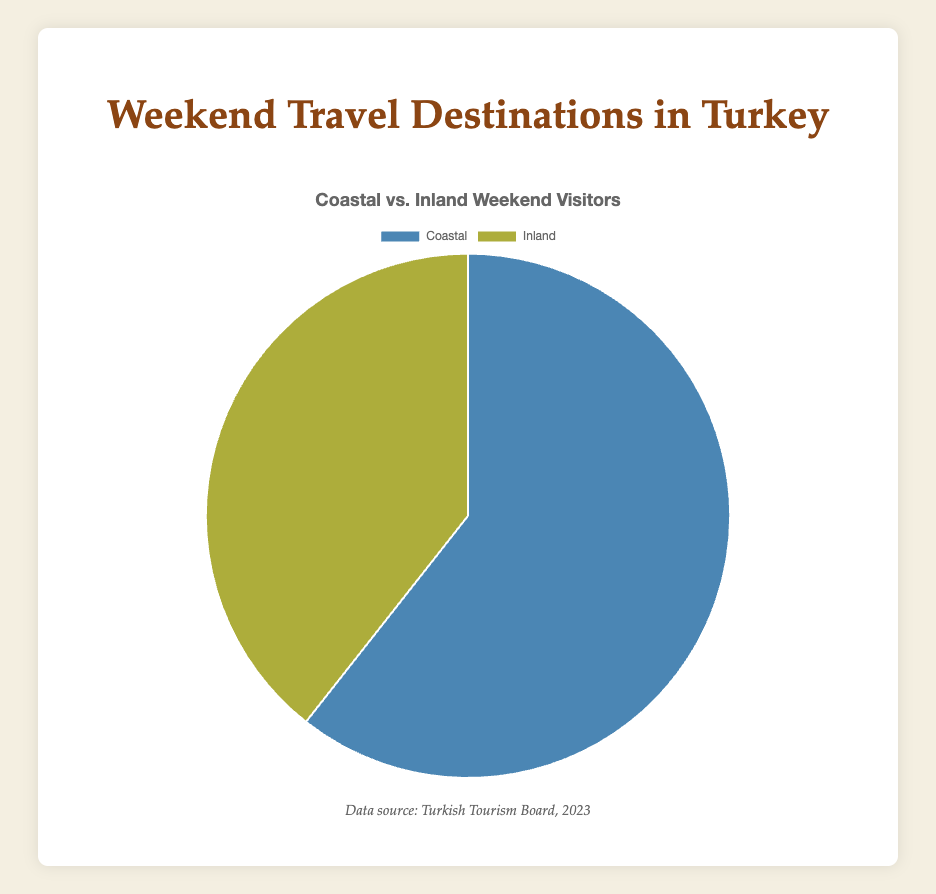What's the total number of weekend visitors to coastal destinations? To find the total number of weekend visitors to coastal destinations, sum up the visitors to Antalya, Bodrum, and Izmir: 50,000 + 30,000 + 20,000 = 100,000
Answer: 100,000 Which destination has the highest number of weekend visitors, coastal or inland? Comparing the totals, coastal destinations have 100,000 visitors and inland destinations have 65,000 visitors; coastal is higher
Answer: Coastal What's the average number of weekend visitors to inland destinations? To find the average, sum up the visitors to Cappadocia, Ankara, and Konya: 40,000 + 15,000 + 10,000 = 65,000. Then divide by 3: 65,000 ÷ 3 ≈ 21,666.67
Answer: 21,666.67 Which color represents coastal destinations in the pie chart? The pie chart uses a legend and the color assignment, coastal destinations are represented by blue shades
Answer: Blue How many more weekend visitors do coastal destinations have compared to inland destinations? To find the difference, subtract inland visitors from coastal visitors: 100,000 - 65,000 = 35,000
Answer: 35,000 What's the percentage of total weekend visitors going to inland destinations? First, calculate the total visitors (coastal + inland): 100,000 + 65,000 = 165,000. Then, find the percentage for inland: (65,000 ÷ 165,000) × 100 ≈ 39.39%
Answer: 39.39% Which destination, coastal or inland, has a higher average number of visitors per location? Find the averages: Coastal: (50,000 + 30,000 + 20,000) ÷ 3 = 33,333.33, Inland: (40,000 + 15,000 + 10,000) ÷ 3 = 21,666.67; coastal has a higher average
Answer: Coastal What's the cumulative percentage of visitors for coastal destinations? Since coastal visitors are 100,000 and the total is 165,000, calculate (100,000 ÷ 165,000) × 100 ≈ 60.61%
Answer: 60.61% How many weekend visitors would coastal destinations need to reach double the number of inland visitors? Inland visitors are 65,000, and double that is 130,000. Coastal already have 100,000. Needed: 130,000 - 100,000 = 30,000 more visitors
Answer: 30,000 